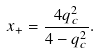Convert formula to latex. <formula><loc_0><loc_0><loc_500><loc_500>x _ { + } = \frac { 4 q _ { c } ^ { 2 } } { 4 - q _ { c } ^ { 2 } } .</formula> 